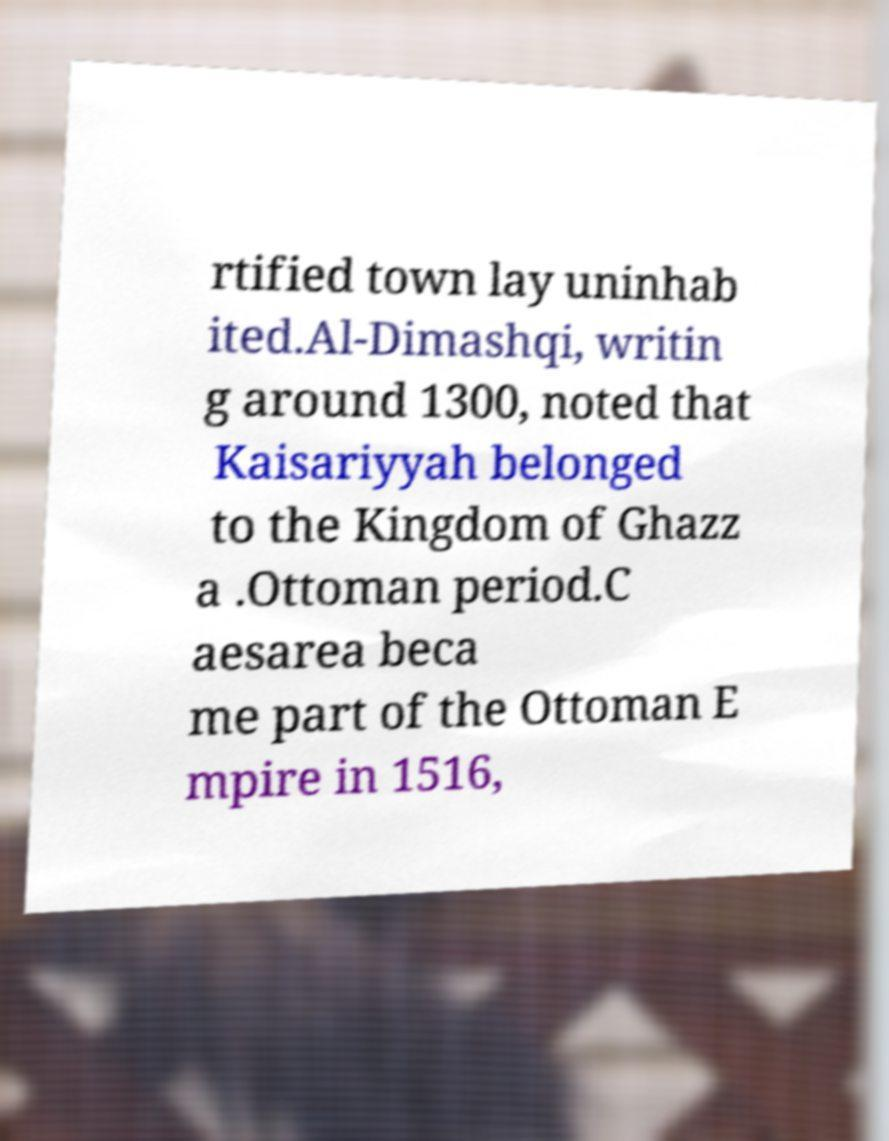Please read and relay the text visible in this image. What does it say? rtified town lay uninhab ited.Al-Dimashqi, writin g around 1300, noted that Kaisariyyah belonged to the Kingdom of Ghazz a .Ottoman period.C aesarea beca me part of the Ottoman E mpire in 1516, 